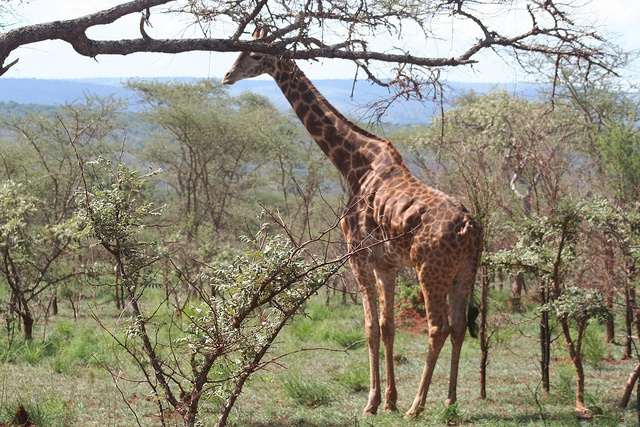Describe the objects in this image and their specific colors. I can see a giraffe in white, maroon, gray, and black tones in this image. 